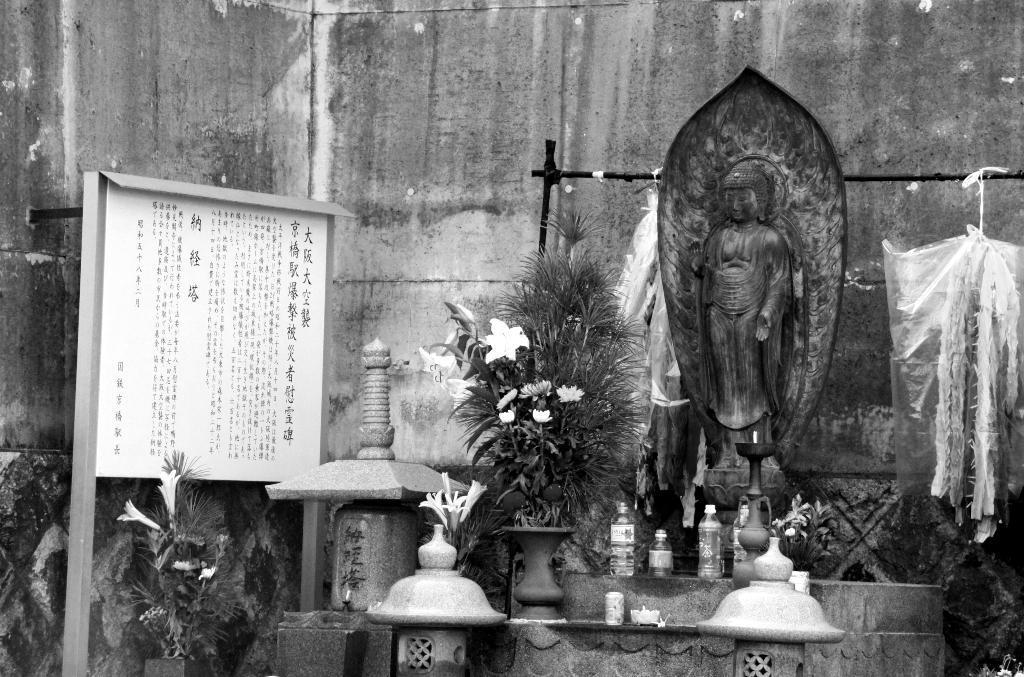Please provide a concise description of this image. This picture shows a statue and few bottles and we see a plant with flowers and we see couple of polythene covers hanging and we see a board with some text on it. 